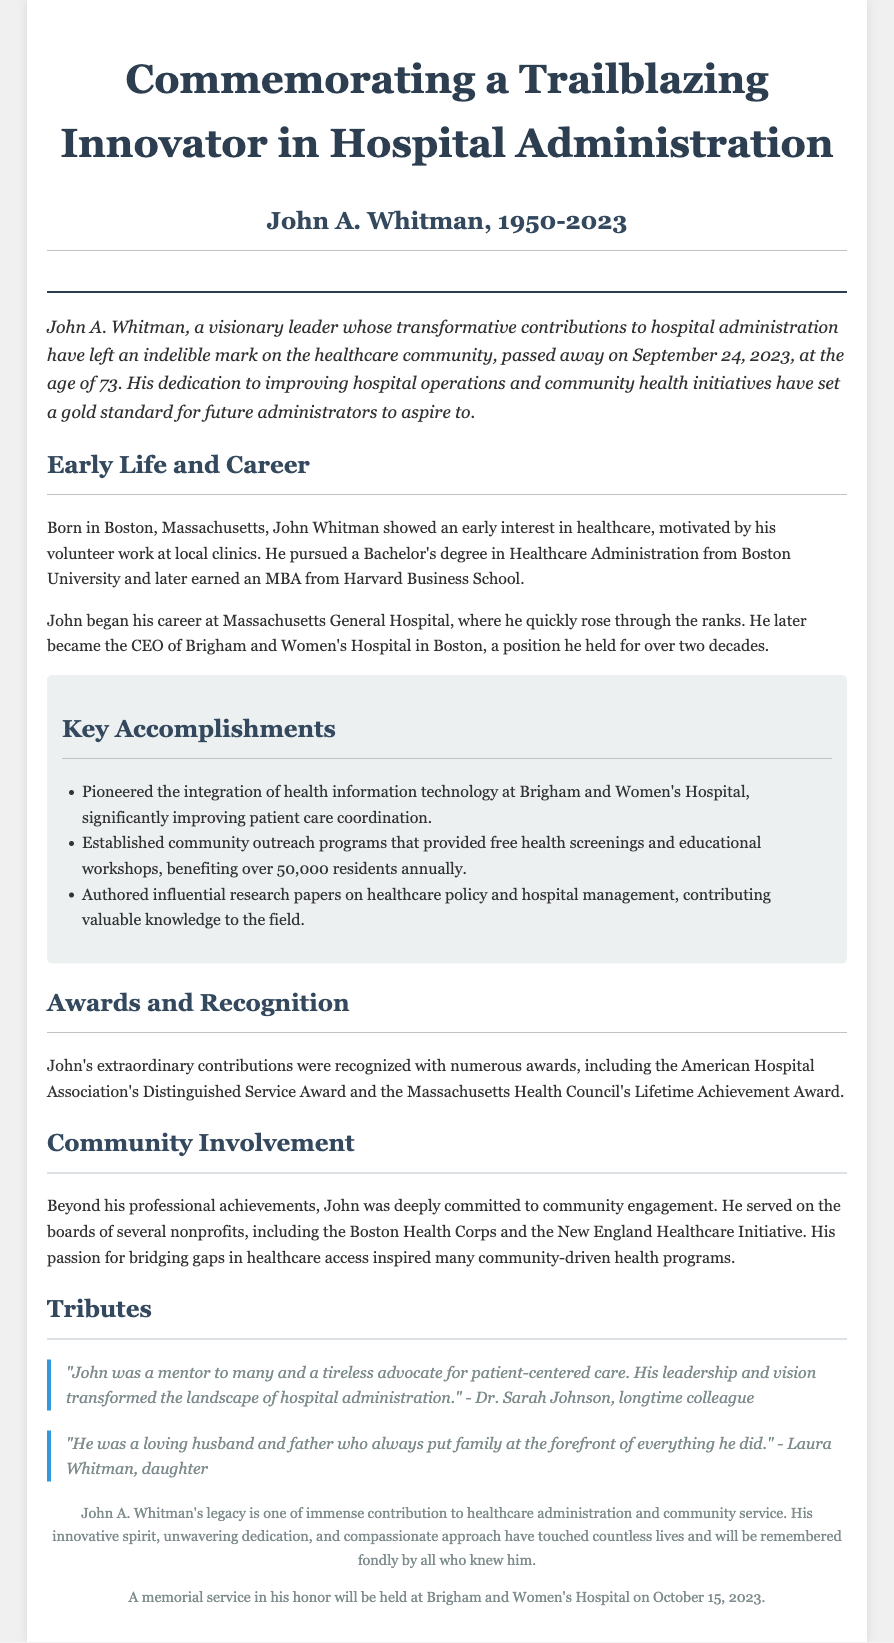What was the birth year of John A. Whitman? John A. Whitman was born in 1950, as stated in the obituary.
Answer: 1950 How old was John A. Whitman when he passed away? John A. Whitman passed away at the age of 73.
Answer: 73 What significant position did John A. Whitman hold for over two decades? The document states that he was the CEO of Brigham and Women's Hospital for over two decades.
Answer: CEO of Brigham and Women's Hospital How many residents benefited from the community outreach programs established by John A. Whitman? The obituary mentions that the programs benefited over 50,000 residents annually.
Answer: 50,000 What prestigious award did John A. Whitman receive from the American Hospital Association? He received the Distinguished Service Award from the American Hospital Association.
Answer: Distinguished Service Award What motivated John A. Whitman to pursue a career in healthcare? The obituary highlights that his early volunteer work at local clinics motivated his interest in healthcare.
Answer: Volunteer work at local clinics What is one key theme described in the tributes section of the obituary? The tributes emphasize John A. Whitman's role as a mentor and advocate for patient-centered care.
Answer: Mentor and advocate for patient-centered care When will the memorial service in honor of John A. Whitman be held? The memorial service is scheduled to take place on October 15, 2023.
Answer: October 15, 2023 What community organizations did John A. Whitman serve on the boards of? The document lists the Boston Health Corps and the New England Healthcare Initiative as organizations he served on.
Answer: Boston Health Corps and New England Healthcare Initiative 